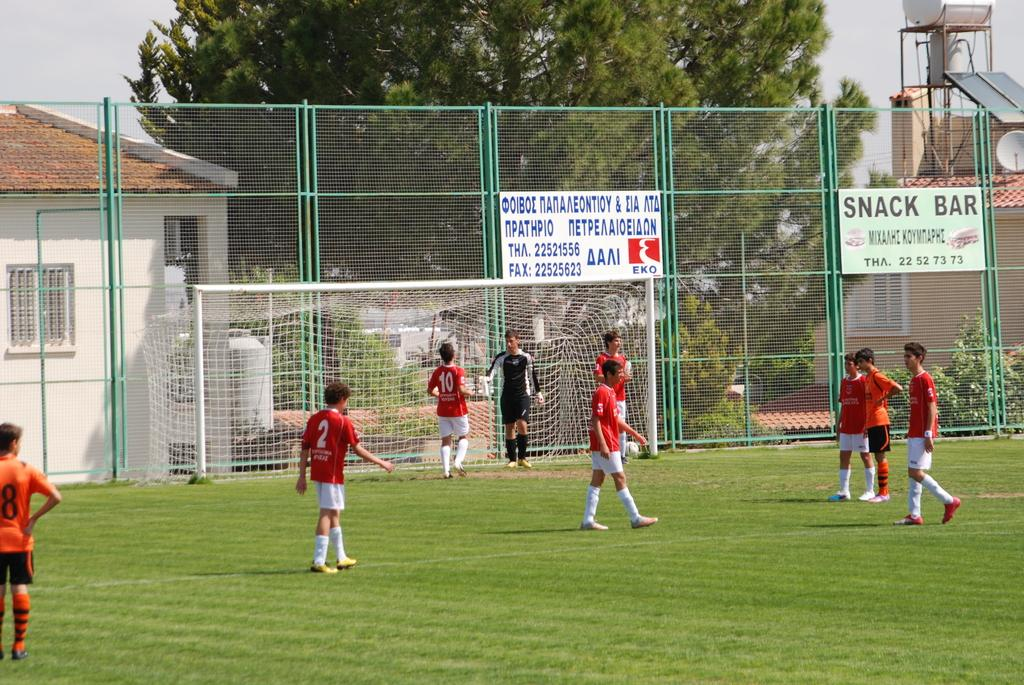<image>
Give a short and clear explanation of the subsequent image. a soccer field with a fence that has a sign for the snack bar 